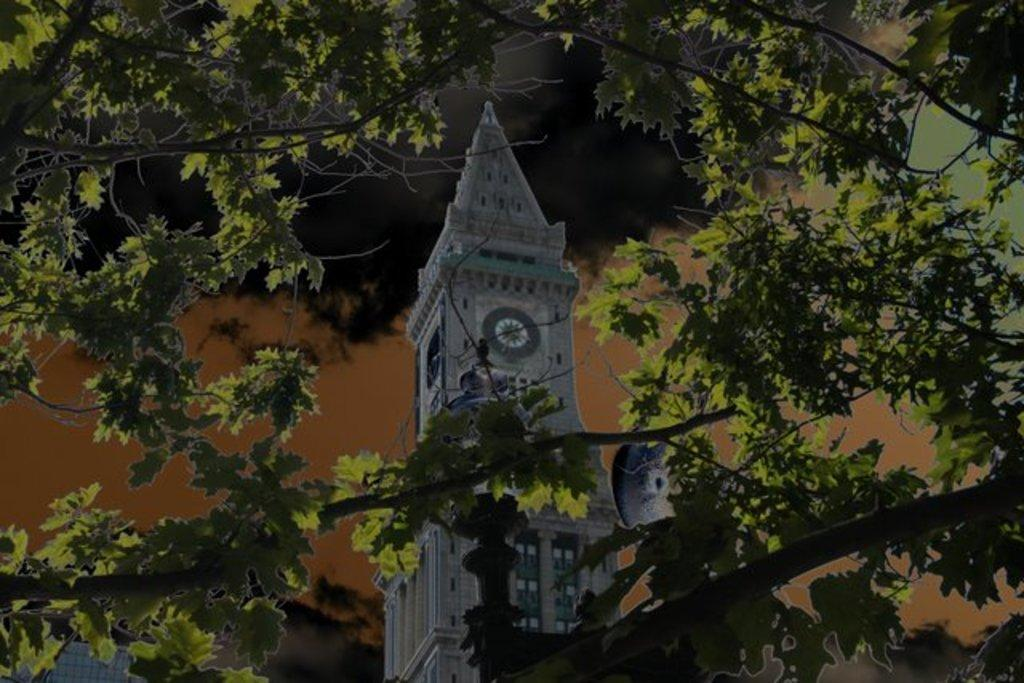What is the main structure in the image? There is a clock tower in the image. What feature is present on the clock tower? The clock tower has a clock on it. What type of natural element is near the clock tower? There is a tree near the clock tower. What type of iron is used to make the governor's top hat in the image? There is no governor or top hat present in the image; it features a clock tower with a clock and a tree nearby. 